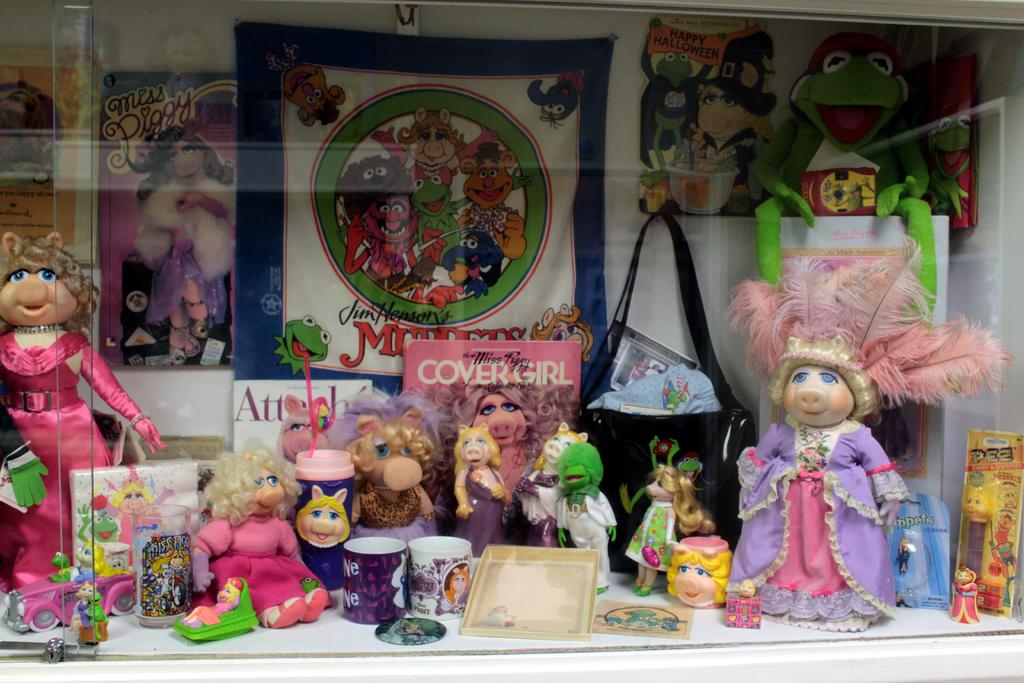<image>
Offer a succinct explanation of the picture presented. A book with the words COVER GIRL on the front is in a display with Miss Piggy memorabilia. 